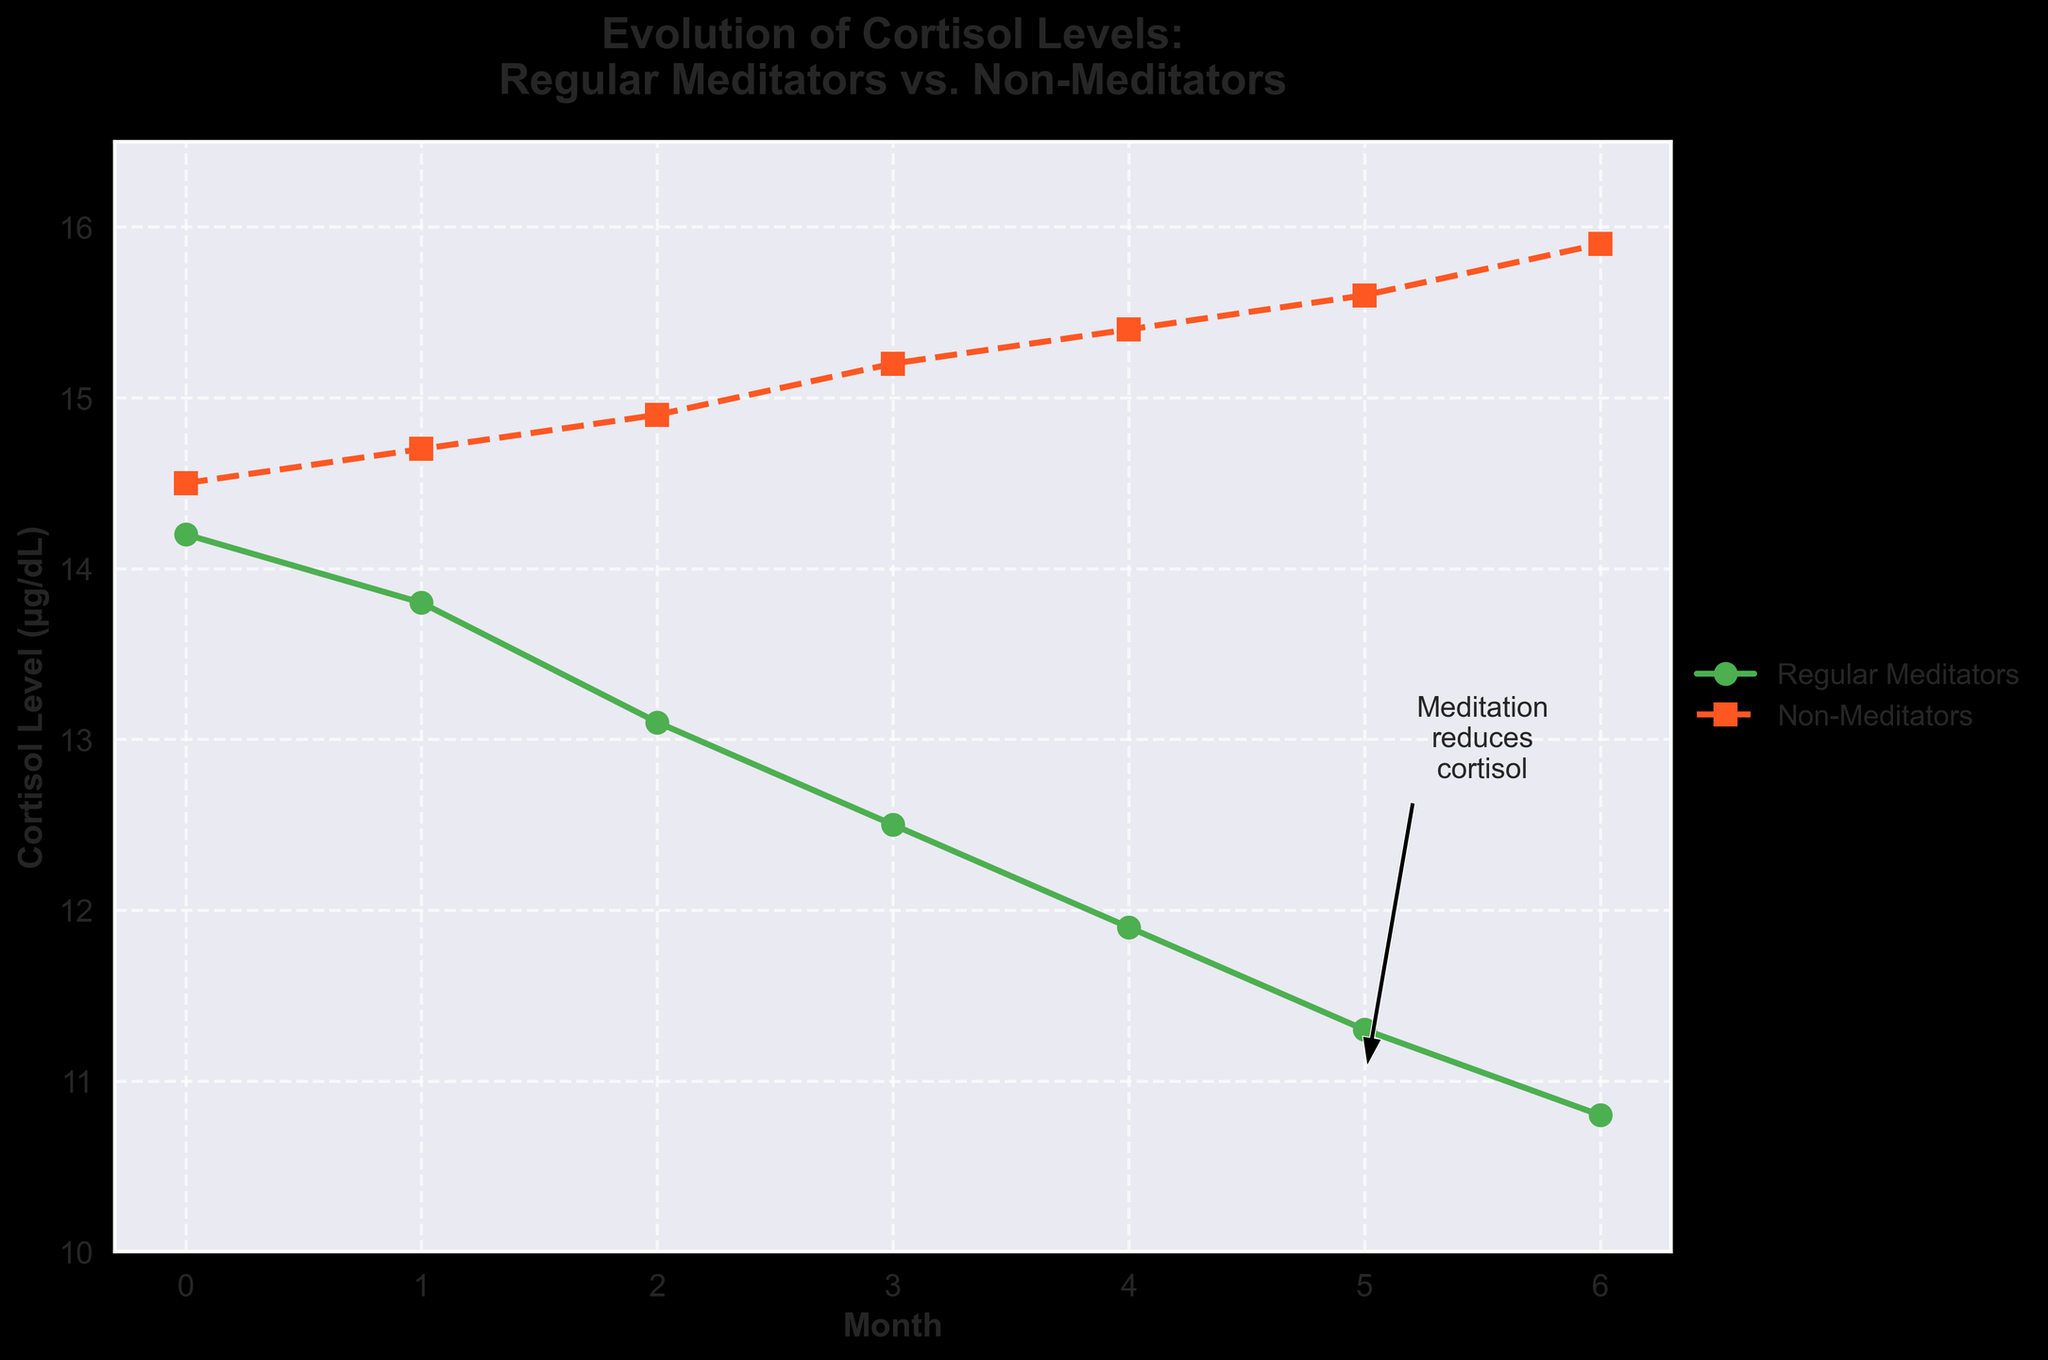What is the difference in cortisol levels between regular meditators and non-meditators at month 6? At month 6, the cortisol level for regular meditators is 10.8 µg/dL and for non-meditators, it is 15.9 µg/dL. The difference is found by subtracting the meditators' level from the non-meditators' level: 15.9 - 10.8 = 5.1 µg/dL.
Answer: 5.1 µg/dL How do the cortisol levels of regular meditators change from month 0 to month 6? The cortisol levels for regular meditators at month 0 is 14.2 µg/dL, and it decreases to 10.8 µg/dL at month 6. The change is found by subtracting the month 6 level from the month 0 level: 14.2 - 10.8 = 3.4 µg/dL.
Answer: Decreases by 3.4 µg/dL Which group shows a greater reduction in cortisol levels over 6 months? The cortisol levels for regular meditators reduce from 14.2 µg/dL to 10.8 µg/dL (a reduction of 3.4 µg/dL). For non-meditators, the levels increase from 14.5 µg/dL to 15.9 µg/dL (an increase of 1.4 µg/dL). Regular meditators show a greater reduction.
Answer: Regular Meditators What visual element indicates the downward trend for regular meditators' cortisol levels? The plot line for regular meditators (green color with circles) shows a consistent downward trend from month 0 to month 6, indicating a decrease in their cortisol levels over time.
Answer: Downward green line with circles Between which months do non-meditators show the greatest increase in cortisol levels? By examining the plot, non-meditators show the greatest increase between month 3 and month 4. The cortisol levels increase from 15.2 µg/dL to 15.4 µg/dL, a 0.2 µg/dL increment.
Answer: Month 3 to month 4 What annotation is included in the plot, and what does it convey? The annotation "Meditation reduces cortisol" is placed near the regular meditators' line around month 5. It includes an arrow pointing to the downward trend of the green line, highlighting the reduction in cortisol levels due to meditation.
Answer: "Meditation reduces cortisol" annotation with arrow How much higher is the cortisol level for non-meditators at month 2 compared to regular meditators? At month 2, the cortisol level for non-meditators is 14.9 µg/dL, and for regular meditators, it is 13.1 µg/dL. The increase is found by subtracting the meditators' level from the non-meditators' level: 14.9 - 13.1 = 1.8 µg/dL.
Answer: 1.8 µg/dL 